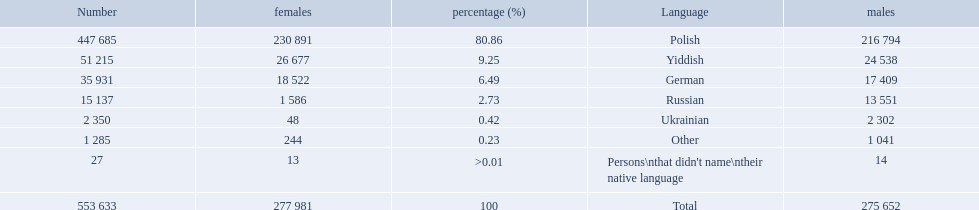What language makes a majority Polish. What the the total number of speakers? 553 633. 